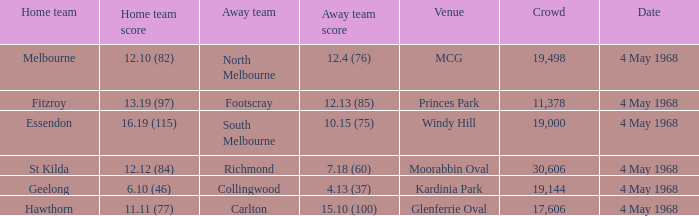How big was the crowd of the team that scored 4.13 (37)? 19144.0. 